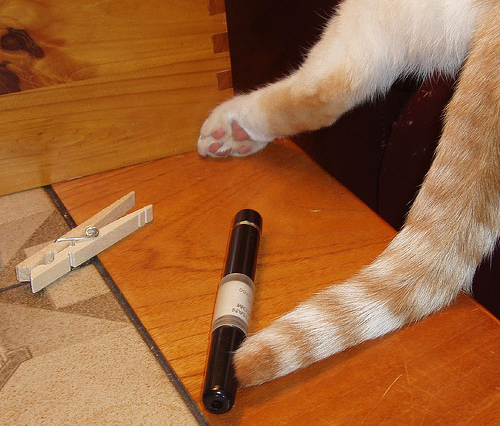<image>
Can you confirm if the cat is behind the cigar? Yes. From this viewpoint, the cat is positioned behind the cigar, with the cigar partially or fully occluding the cat. 